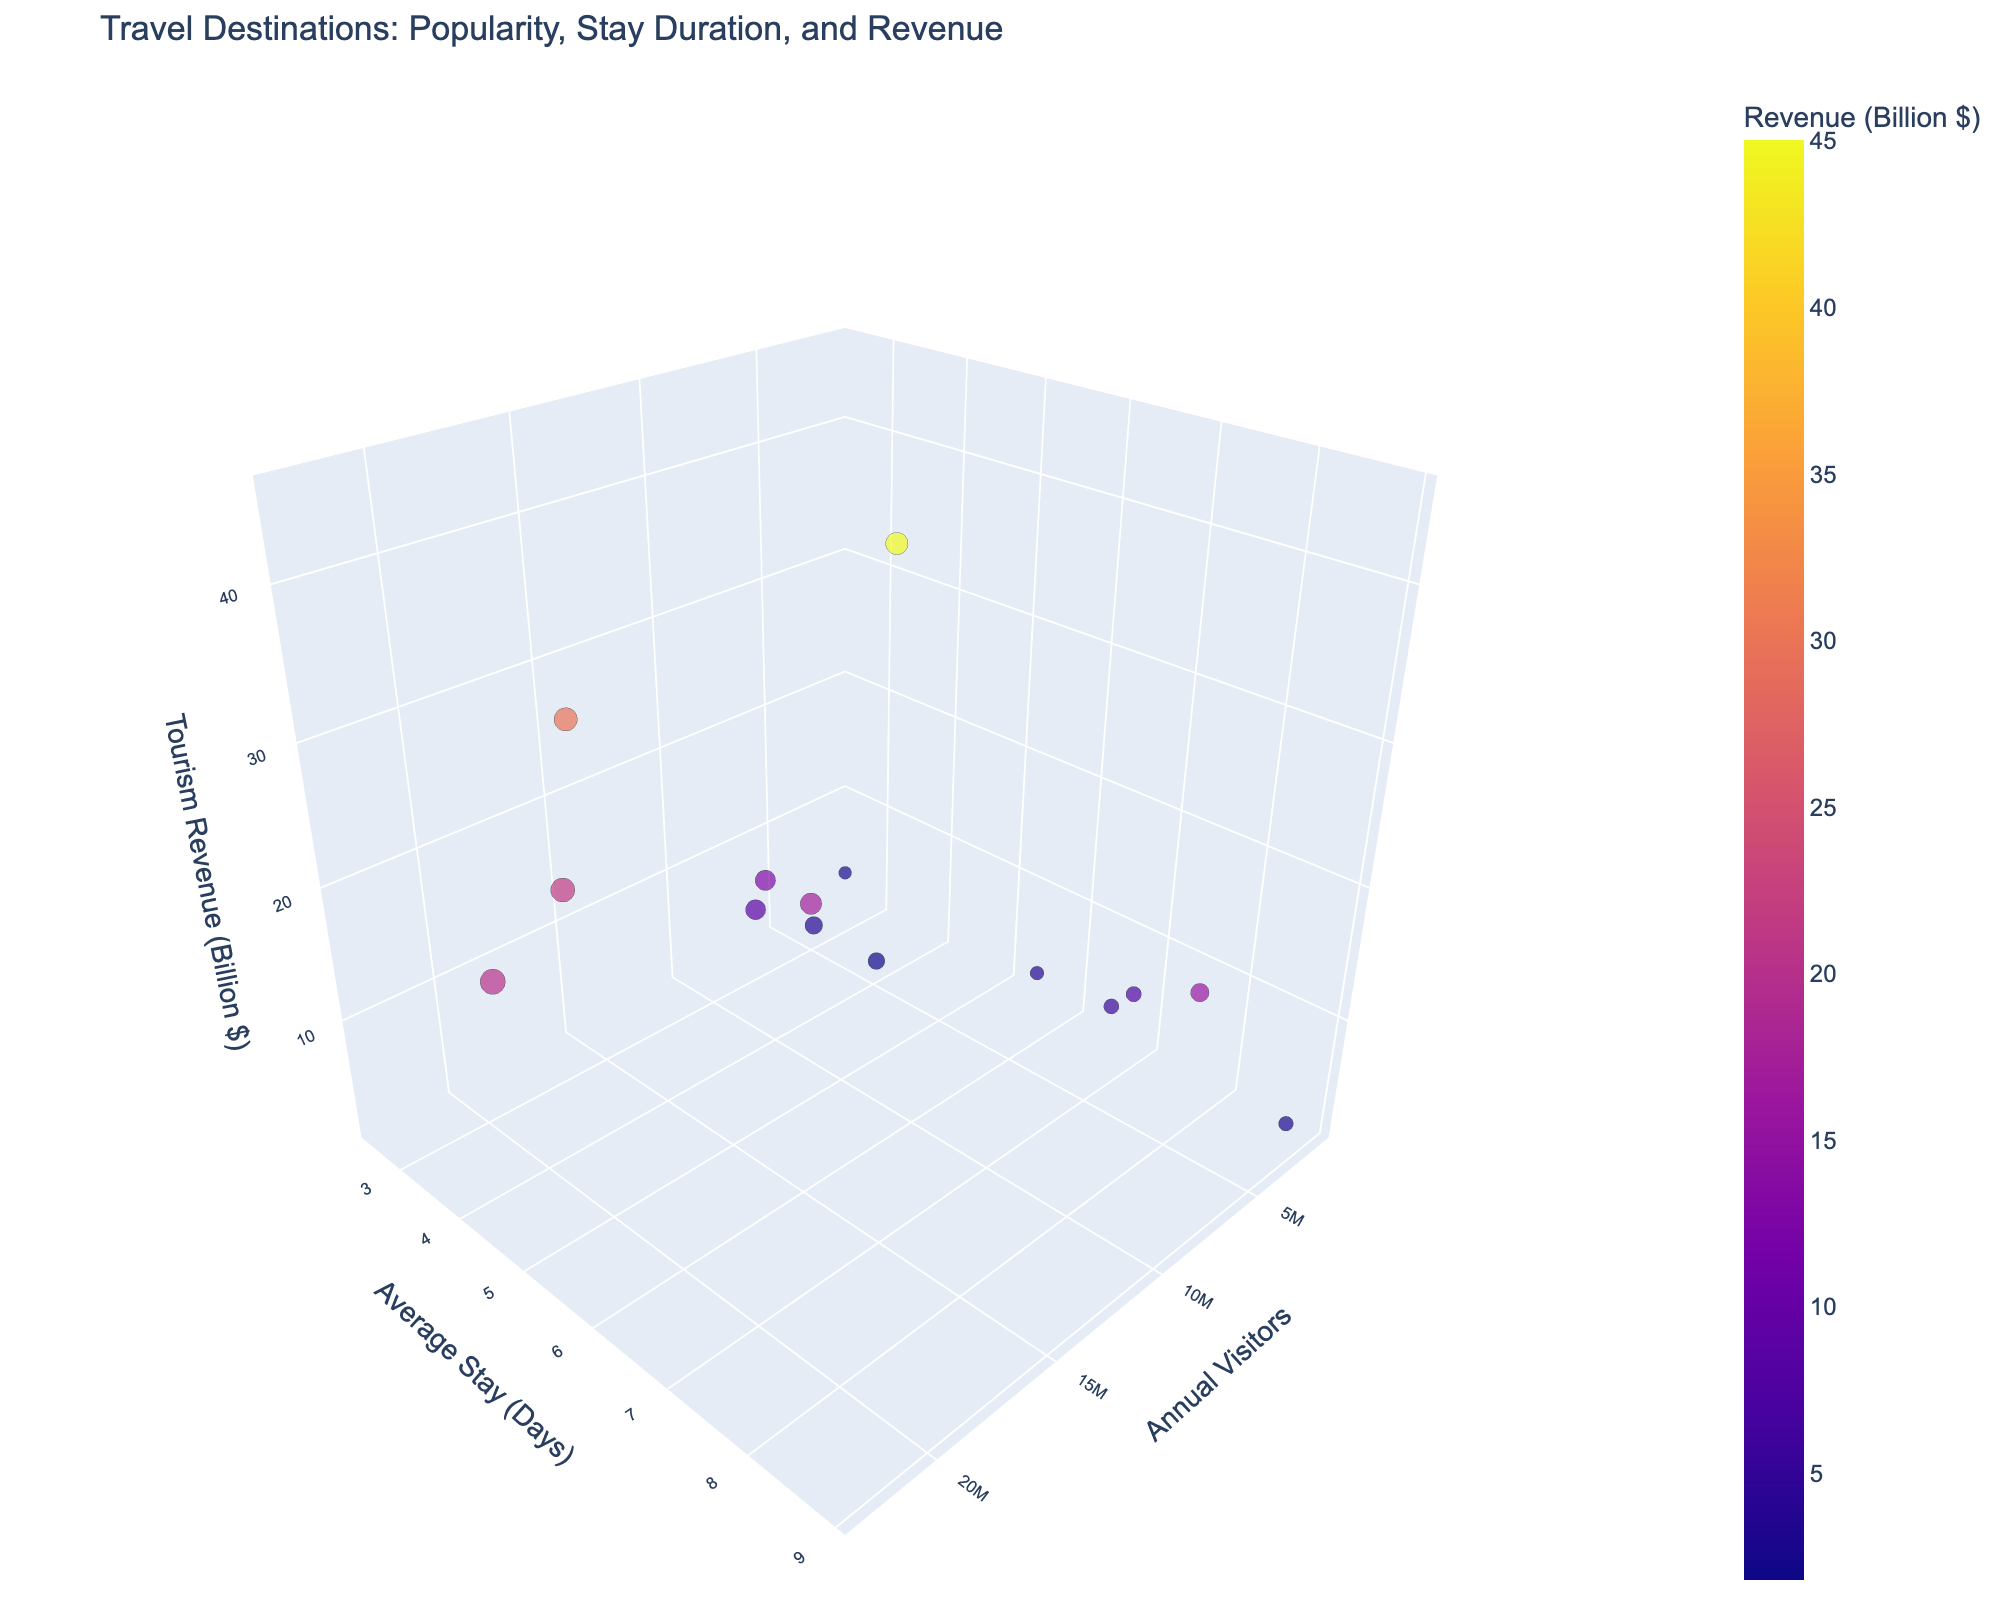what is the title of the plot? The title of the plot is usually displayed prominently at the top of the figure. In this case, the code specifies 'Travel Destinations: Popularity, Stay Duration, and Revenue' as the title.
Answer: Travel Destinations: Popularity, Stay Duration, and Revenue How many destinations are shown on the plot? Since each destination on the plot corresponds to a unique data point, count the bubbles to find the number of destinations. The data lists 15 destinations.
Answer: 15 Which destination has the highest number of annual visitors? Examine the 'Annual Visitors' axis values for the highest point. The data shows Bangkok as having the highest number of annual visitors with 22.78 million.
Answer: Bangkok Which destination generates the lowest tourism revenue? Check the values on the 'Tourism Revenue (Billion $)' axis for the smallest value. The lowest revenue is by Kyoto with 1.8 billion dollars.
Answer: Kyoto What is the average stay duration for Marrakech? Find the bubble for Marrakech and review the label on the 'Average Stay (Days)' axis. Marrakech has an average stay duration of 7.1 days.
Answer: 7.1 days Which destination has the largest bubble size and why? The bubble size is proportional to the square root of the number of visitors. Therefore, the destination with the most visitors has the largest bubble size, which is Bangkok with 22.78 million visitors.
Answer: Bangkok How does the average stay duration in Bali compare to Tokyo? Locate the bubbles for Bali and Tokyo, and compare their positions on the 'Avg Stay (Days)' axis. Bali has an average stay of 8.5 days while Tokyo has 3.8 days. Bali's stay duration is higher.
Answer: Bali has a longer stay duration How much revenue does Paris generate annually compared to that of Venice? Compare the positions of Paris and Venice on the 'Tourism Revenue (Billion $)' axis. Paris generates 21.5 billion dollars, while Venice generates 3.8 billion dollars. Paris generates more revenue.
Answer: Paris generates more What is the total tourism revenue for New York City and Dubai combined? Identify the revenue values for both destinations and sum them. New York City has 45 billion dollars, and Dubai has 29.7 billion dollars, totaling 74.7 billion dollars.
Answer: 74.7 billion dollars Which destination has the shortest average stay duration, and what is its impact? Look for the smallest value on the ‘Average Stay (Days)’ axis. Machu Picchu has the shortest stay duration of 2.5 days which might indicate either a focused sightseeing spot or limited accommodation options affecting longer stays.
Answer: Machu Picchu, 2.5 days 